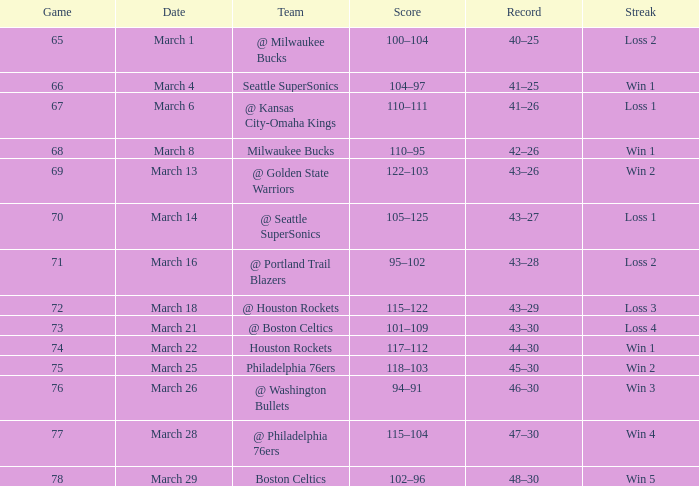What is the lowest Game, when Date is March 21? 73.0. 